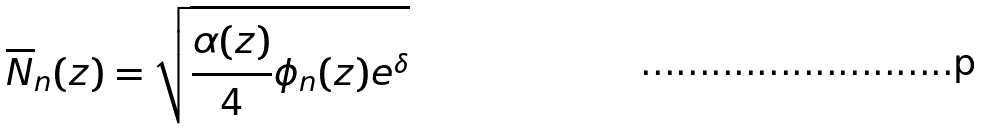<formula> <loc_0><loc_0><loc_500><loc_500>\overline { N } _ { n } ( z ) = \sqrt { \frac { \alpha ( z ) } { 4 } \phi _ { n } ( z ) e ^ { \delta } }</formula> 